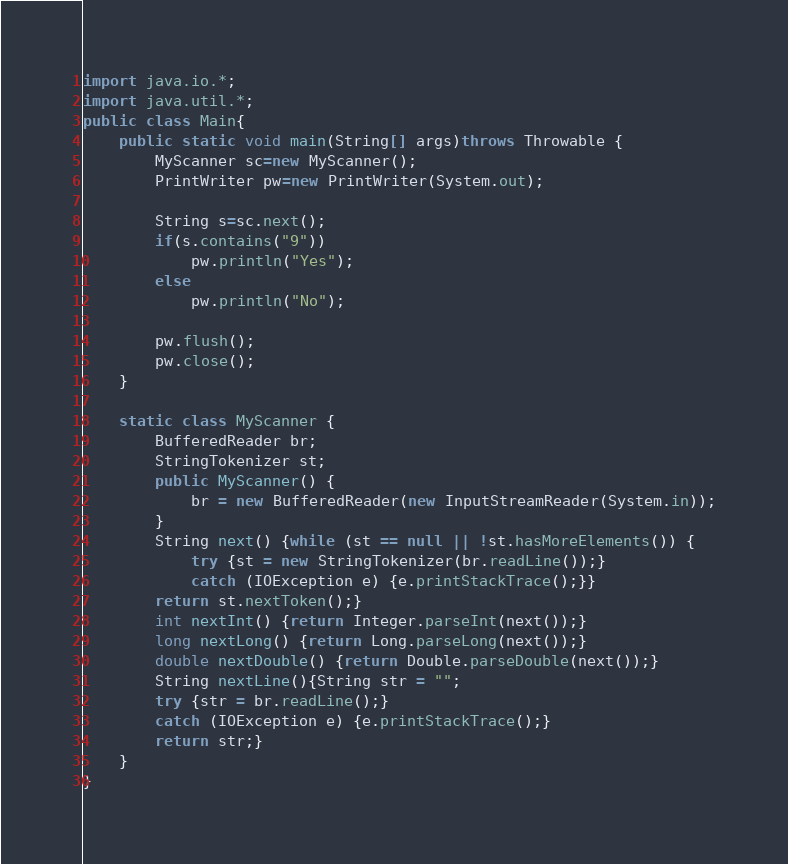Convert code to text. <code><loc_0><loc_0><loc_500><loc_500><_Java_>import java.io.*;
import java.util.*;
public class Main{
	public static void main(String[] args)throws Throwable {
		MyScanner sc=new MyScanner();
		PrintWriter pw=new PrintWriter(System.out);
		
		String s=sc.next();
		if(s.contains("9"))
			pw.println("Yes");
		else
			pw.println("No");
		
		pw.flush();
		pw.close();
	}
	
	static class MyScanner {
		BufferedReader br;
		StringTokenizer st;
		public MyScanner() {
			br = new BufferedReader(new InputStreamReader(System.in));
		}
		String next() {while (st == null || !st.hasMoreElements()) {
			try {st = new StringTokenizer(br.readLine());}
			catch (IOException e) {e.printStackTrace();}}
		return st.nextToken();}
		int nextInt() {return Integer.parseInt(next());}
		long nextLong() {return Long.parseLong(next());}
		double nextDouble() {return Double.parseDouble(next());}
		String nextLine(){String str = "";
		try {str = br.readLine();}
		catch (IOException e) {e.printStackTrace();}
		return str;}
	}
}</code> 